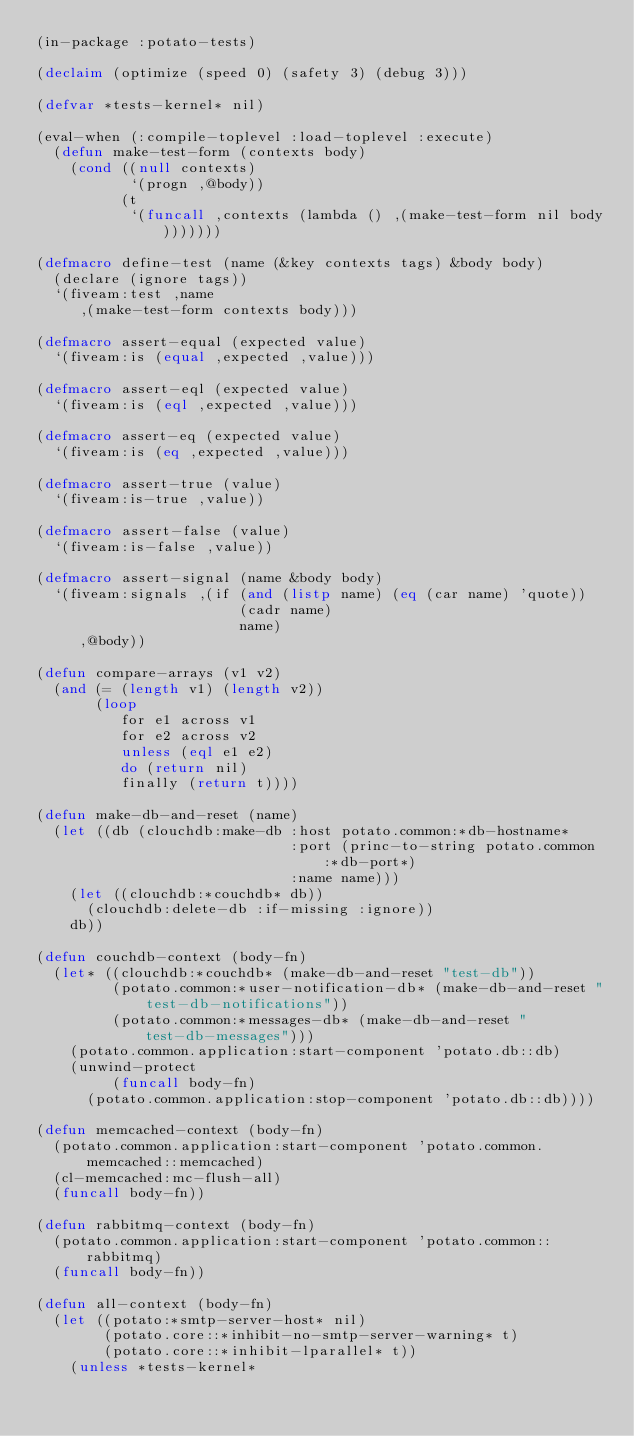<code> <loc_0><loc_0><loc_500><loc_500><_Lisp_>(in-package :potato-tests)

(declaim (optimize (speed 0) (safety 3) (debug 3)))

(defvar *tests-kernel* nil)

(eval-when (:compile-toplevel :load-toplevel :execute)
  (defun make-test-form (contexts body)
    (cond ((null contexts)
           `(progn ,@body))
          (t
           `(funcall ,contexts (lambda () ,(make-test-form nil body)))))))

(defmacro define-test (name (&key contexts tags) &body body)
  (declare (ignore tags))
  `(fiveam:test ,name
     ,(make-test-form contexts body)))

(defmacro assert-equal (expected value)
  `(fiveam:is (equal ,expected ,value)))

(defmacro assert-eql (expected value)
  `(fiveam:is (eql ,expected ,value)))

(defmacro assert-eq (expected value)
  `(fiveam:is (eq ,expected ,value)))

(defmacro assert-true (value)
  `(fiveam:is-true ,value))

(defmacro assert-false (value)
  `(fiveam:is-false ,value))

(defmacro assert-signal (name &body body)
  `(fiveam:signals ,(if (and (listp name) (eq (car name) 'quote))
                        (cadr name)
                        name)
     ,@body))

(defun compare-arrays (v1 v2)
  (and (= (length v1) (length v2))
       (loop
          for e1 across v1
          for e2 across v2
          unless (eql e1 e2)
          do (return nil)
          finally (return t))))

(defun make-db-and-reset (name)
  (let ((db (clouchdb:make-db :host potato.common:*db-hostname*
                              :port (princ-to-string potato.common:*db-port*)
                              :name name)))
    (let ((clouchdb:*couchdb* db))
      (clouchdb:delete-db :if-missing :ignore))
    db))

(defun couchdb-context (body-fn)
  (let* ((clouchdb:*couchdb* (make-db-and-reset "test-db"))
         (potato.common:*user-notification-db* (make-db-and-reset "test-db-notifications"))
         (potato.common:*messages-db* (make-db-and-reset "test-db-messages")))
    (potato.common.application:start-component 'potato.db::db)
    (unwind-protect
         (funcall body-fn)
      (potato.common.application:stop-component 'potato.db::db))))

(defun memcached-context (body-fn)
  (potato.common.application:start-component 'potato.common.memcached::memcached)
  (cl-memcached:mc-flush-all)
  (funcall body-fn))

(defun rabbitmq-context (body-fn)
  (potato.common.application:start-component 'potato.common::rabbitmq)
  (funcall body-fn))

(defun all-context (body-fn)
  (let ((potato:*smtp-server-host* nil)
        (potato.core::*inhibit-no-smtp-server-warning* t)
        (potato.core::*inhibit-lparallel* t))
    (unless *tests-kernel*</code> 